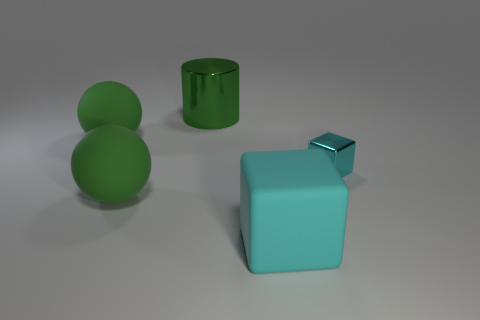The thing that is to the right of the shiny cylinder and to the left of the tiny cyan shiny block has what shape?
Your answer should be compact. Cube. What number of things are made of the same material as the large cylinder?
Provide a short and direct response. 1. There is a cyan cube behind the large cyan matte cube; what number of big cylinders are to the left of it?
Your answer should be very brief. 1. What shape is the big green rubber object that is in front of the big ball that is behind the metallic thing on the right side of the big cube?
Make the answer very short. Sphere. There is a metallic thing that is the same color as the large matte block; what is its size?
Provide a succinct answer. Small. What number of things are small purple metal cylinders or big green metal objects?
Provide a succinct answer. 1. What is the color of the cylinder that is the same size as the rubber block?
Provide a short and direct response. Green. Is the shape of the big cyan thing the same as the shiny thing that is in front of the green metal thing?
Make the answer very short. Yes. What number of things are either large green things that are left of the big green metallic object or things on the right side of the large matte block?
Give a very brief answer. 3. What is the shape of the rubber thing that is the same color as the small block?
Offer a very short reply. Cube. 